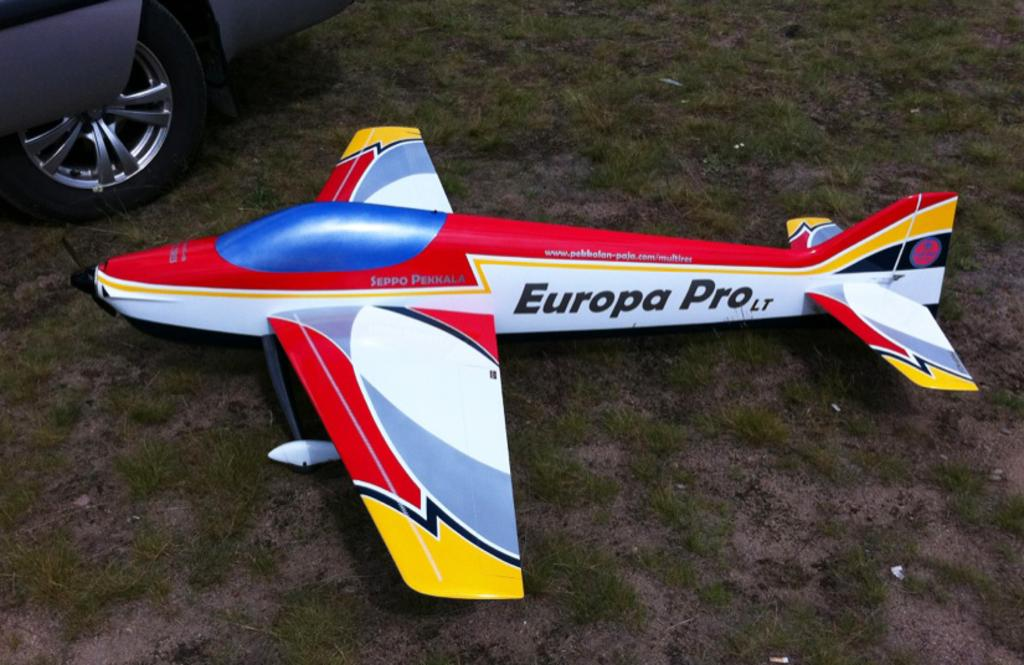<image>
Offer a succinct explanation of the picture presented. A model airplane called the Europa Pro is sitting on the ground outside. 